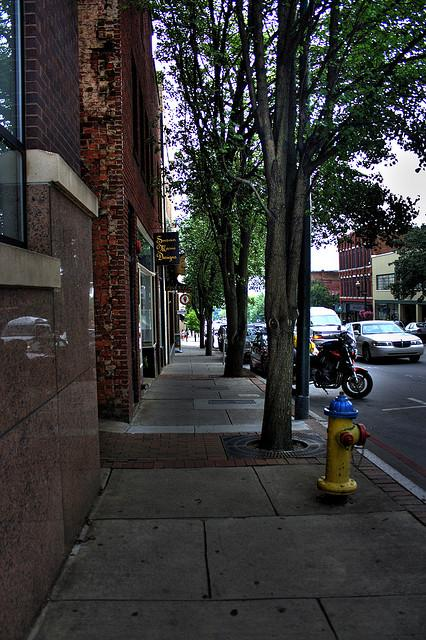What is the yellow object on the sidewalk connected to? Please explain your reasoning. water lines. Firefighters use the yellow object, which is a fire hydrant, to put of fires. 